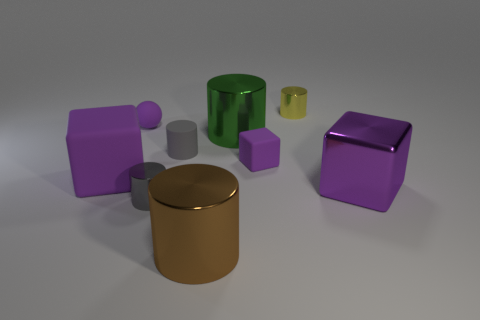There is a large thing that is both on the left side of the purple metal cube and in front of the large purple matte thing; what is it made of?
Offer a very short reply. Metal. There is a shiny cube; does it have the same color as the small metallic cylinder that is in front of the yellow thing?
Provide a succinct answer. No. There is a gray metal object that is the same shape as the tiny yellow object; what size is it?
Provide a short and direct response. Small. There is a rubber object that is in front of the tiny purple sphere and left of the gray shiny cylinder; what shape is it?
Ensure brevity in your answer.  Cube. There is a sphere; does it have the same size as the matte thing that is to the left of the small purple sphere?
Give a very brief answer. No. There is another tiny metallic thing that is the same shape as the small gray metallic object; what is its color?
Your response must be concise. Yellow. There is a cube that is to the right of the tiny yellow object; is it the same size as the green object in front of the yellow object?
Your answer should be compact. Yes. Is the shape of the purple metal thing the same as the brown thing?
Your response must be concise. No. What number of objects are small metal cylinders on the right side of the brown metallic object or big purple cubes?
Give a very brief answer. 3. Are there any yellow shiny objects that have the same shape as the gray metallic thing?
Your response must be concise. Yes. 